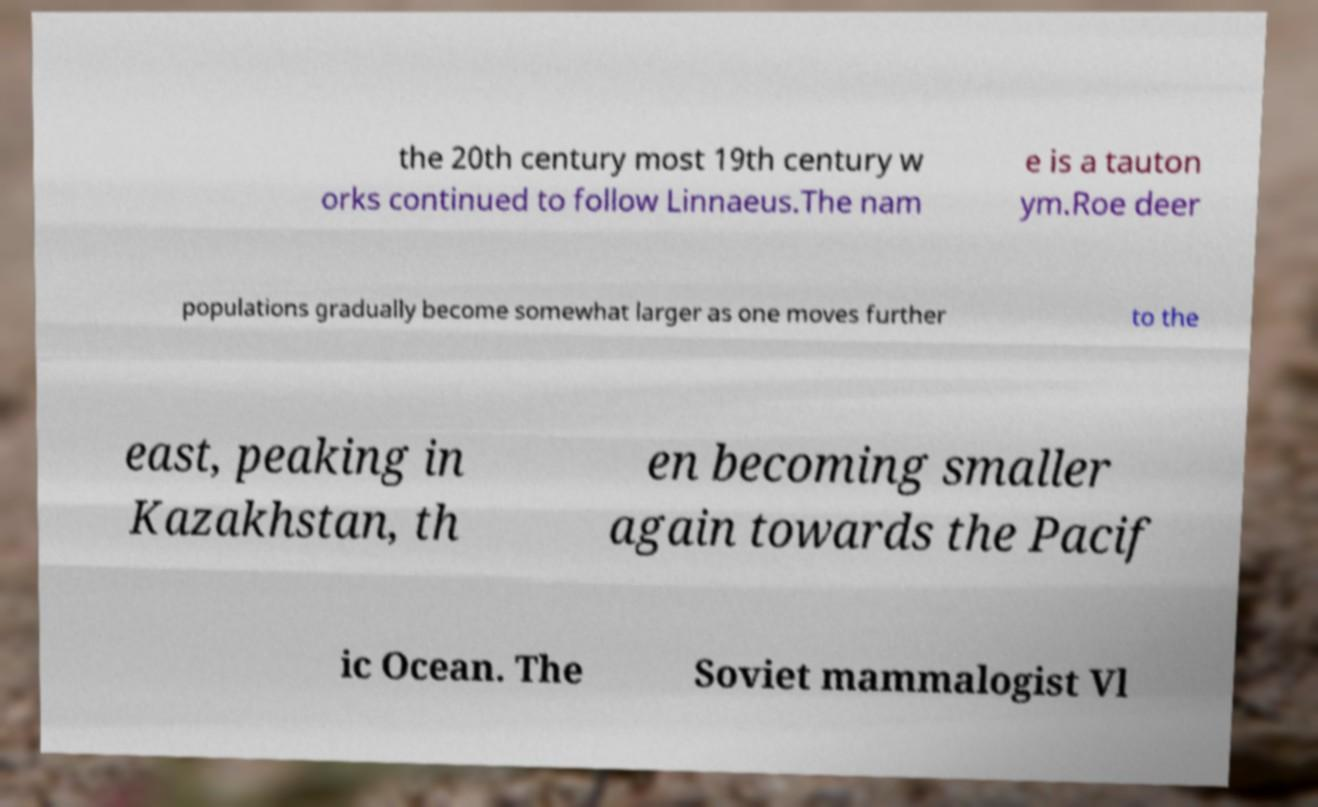Can you read and provide the text displayed in the image?This photo seems to have some interesting text. Can you extract and type it out for me? the 20th century most 19th century w orks continued to follow Linnaeus.The nam e is a tauton ym.Roe deer populations gradually become somewhat larger as one moves further to the east, peaking in Kazakhstan, th en becoming smaller again towards the Pacif ic Ocean. The Soviet mammalogist Vl 